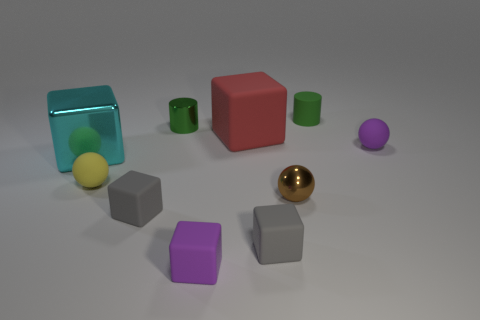Subtract 2 cubes. How many cubes are left? 3 Subtract all brown blocks. Subtract all yellow cylinders. How many blocks are left? 5 Subtract all cylinders. How many objects are left? 8 Add 5 cyan metallic things. How many cyan metallic things are left? 6 Add 7 metallic objects. How many metallic objects exist? 10 Subtract 0 blue blocks. How many objects are left? 10 Subtract all gray rubber cubes. Subtract all tiny metallic cylinders. How many objects are left? 7 